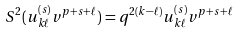Convert formula to latex. <formula><loc_0><loc_0><loc_500><loc_500>S ^ { 2 } ( u ^ { ( s ) } _ { k \ell } v ^ { p + s + \ell } ) = q ^ { 2 ( k - \ell ) } u ^ { ( s ) } _ { k \ell } v ^ { p + s + \ell }</formula> 